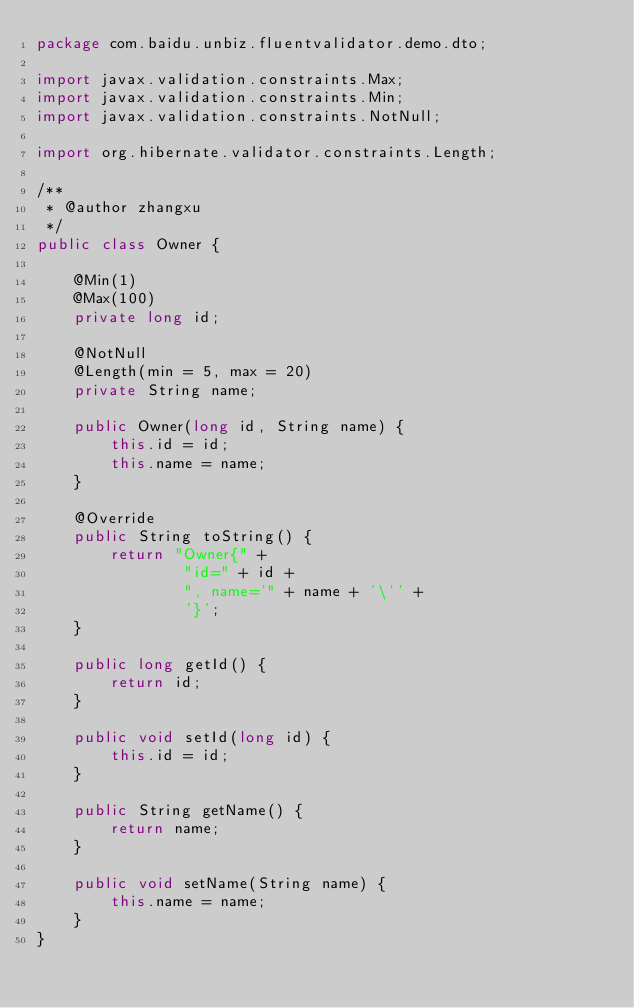Convert code to text. <code><loc_0><loc_0><loc_500><loc_500><_Java_>package com.baidu.unbiz.fluentvalidator.demo.dto;

import javax.validation.constraints.Max;
import javax.validation.constraints.Min;
import javax.validation.constraints.NotNull;

import org.hibernate.validator.constraints.Length;

/**
 * @author zhangxu
 */
public class Owner {

    @Min(1)
    @Max(100)
    private long id;

    @NotNull
    @Length(min = 5, max = 20)
    private String name;

    public Owner(long id, String name) {
        this.id = id;
        this.name = name;
    }

    @Override
    public String toString() {
        return "Owner{" +
                "id=" + id +
                ", name='" + name + '\'' +
                '}';
    }

    public long getId() {
        return id;
    }

    public void setId(long id) {
        this.id = id;
    }

    public String getName() {
        return name;
    }

    public void setName(String name) {
        this.name = name;
    }
}
</code> 